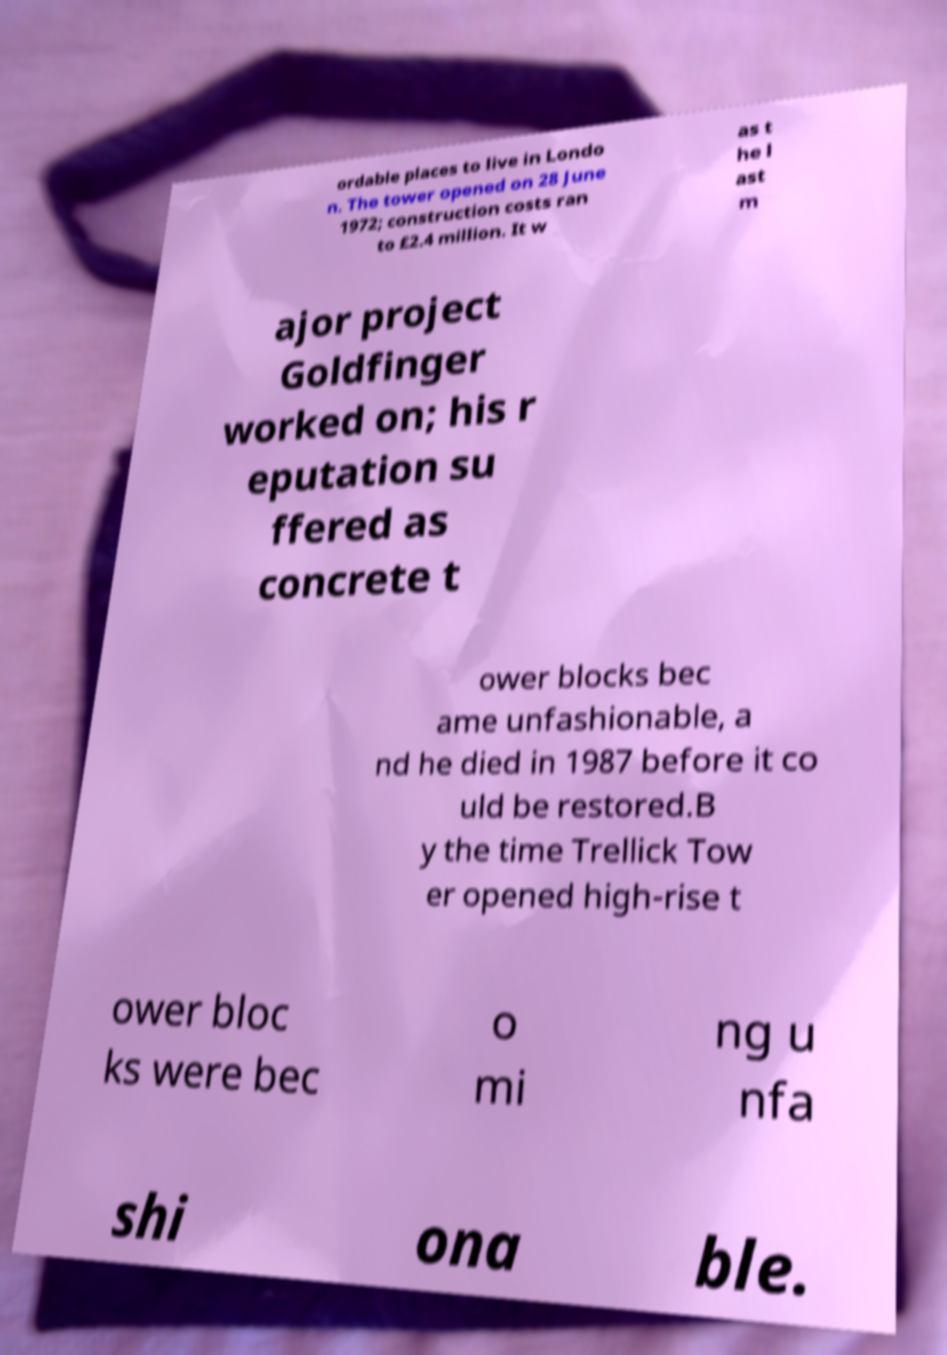For documentation purposes, I need the text within this image transcribed. Could you provide that? ordable places to live in Londo n. The tower opened on 28 June 1972; construction costs ran to £2.4 million. It w as t he l ast m ajor project Goldfinger worked on; his r eputation su ffered as concrete t ower blocks bec ame unfashionable, a nd he died in 1987 before it co uld be restored.B y the time Trellick Tow er opened high-rise t ower bloc ks were bec o mi ng u nfa shi ona ble. 